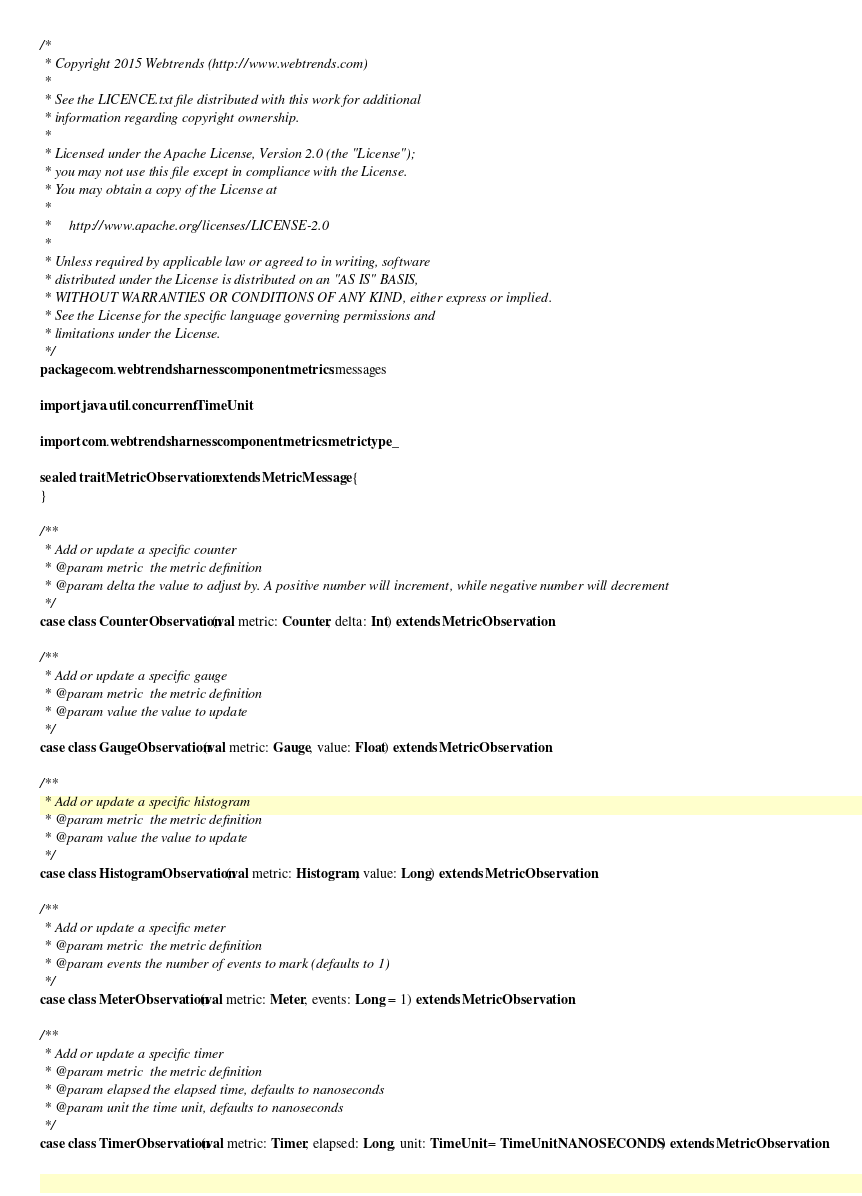<code> <loc_0><loc_0><loc_500><loc_500><_Scala_>/*
 * Copyright 2015 Webtrends (http://www.webtrends.com)
 *
 * See the LICENCE.txt file distributed with this work for additional
 * information regarding copyright ownership.
 *
 * Licensed under the Apache License, Version 2.0 (the "License");
 * you may not use this file except in compliance with the License.
 * You may obtain a copy of the License at
 *
 *     http://www.apache.org/licenses/LICENSE-2.0
 *
 * Unless required by applicable law or agreed to in writing, software
 * distributed under the License is distributed on an "AS IS" BASIS,
 * WITHOUT WARRANTIES OR CONDITIONS OF ANY KIND, either express or implied.
 * See the License for the specific language governing permissions and
 * limitations under the License.
 */
package com.webtrends.harness.component.metrics.messages

import java.util.concurrent.TimeUnit

import com.webtrends.harness.component.metrics.metrictype._

sealed trait MetricObservation extends MetricMessage {
}

/**
 * Add or update a specific counter
 * @param metric  the metric definition
 * @param delta the value to adjust by. A positive number will increment, while negative number will decrement
 */
case class CounterObservation(val metric: Counter, delta: Int) extends MetricObservation

/**
 * Add or update a specific gauge
 * @param metric  the metric definition
 * @param value the value to update
 */
case class GaugeObservation(val metric: Gauge, value: Float) extends MetricObservation

/**
 * Add or update a specific histogram
 * @param metric  the metric definition
 * @param value the value to update
 */
case class HistogramObservation(val metric: Histogram, value: Long) extends MetricObservation

/**
 * Add or update a specific meter
 * @param metric  the metric definition
 * @param events the number of events to mark (defaults to 1)
 */
case class MeterObservation(val metric: Meter, events: Long = 1) extends MetricObservation

/**
 * Add or update a specific timer
 * @param metric  the metric definition
 * @param elapsed the elapsed time, defaults to nanoseconds
 * @param unit the time unit, defaults to nanoseconds
 */
case class TimerObservation(val metric: Timer, elapsed: Long, unit: TimeUnit = TimeUnit.NANOSECONDS) extends MetricObservation</code> 